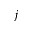<formula> <loc_0><loc_0><loc_500><loc_500>j</formula> 